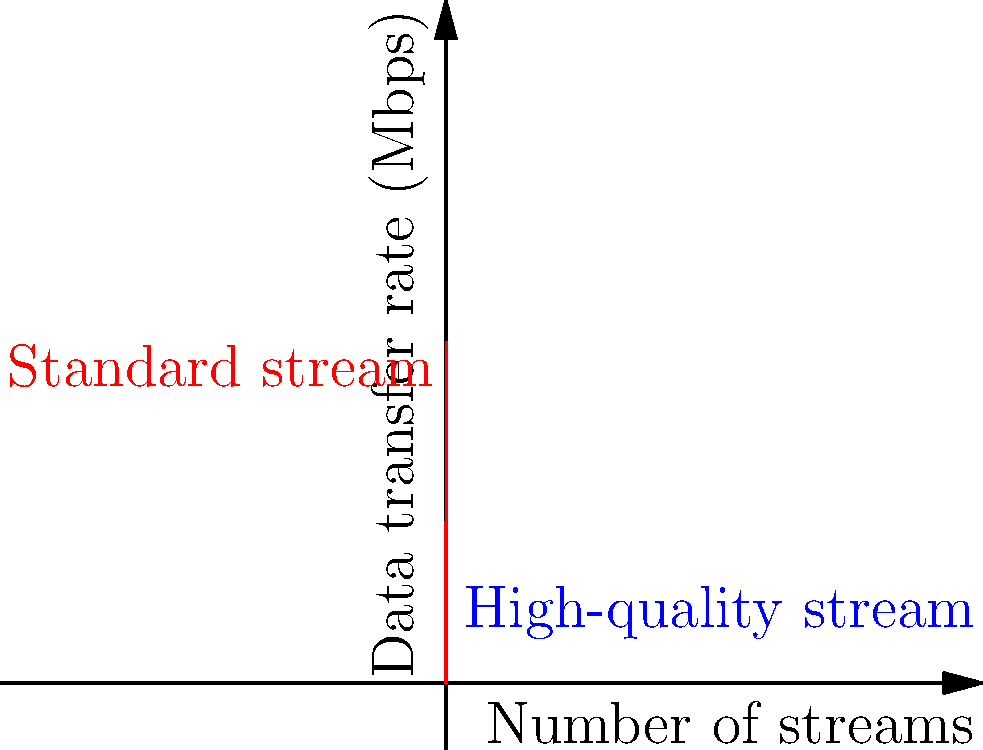A live event producer is setting up a video streaming system for a multi-camera production. The data transfer rate (in Mbps) for high-quality streams is modeled by the function $f(x) = 50x^2$, where $x$ is the number of simultaneous streams. For standard quality streams, the rate is modeled by $g(x) = 500x$. At what number of streams does the data transfer rate for high-quality streams surpass that of standard streams? What is the rate at this crossover point? To solve this problem, we need to find the point where the two functions intersect:

1) Set the functions equal to each other:
   $50x^2 = 500x$

2) Rearrange the equation:
   $50x^2 - 500x = 0$

3) Factor out the common term:
   $50x(x - 10) = 0$

4) Solve for x:
   $x = 0$ or $x = 10$
   Since we're dealing with a positive number of streams, $x = 10$ is our solution.

5) To find the rate at this crossover point, we can substitute $x = 10$ into either function:
   $f(10) = 50(10)^2 = 5000$ Mbps
   $g(10) = 500(10) = 5000$ Mbps

Therefore, the high-quality stream surpasses the standard stream at 10 simultaneous streams, with a data transfer rate of 5000 Mbps.
Answer: 10 streams; 5000 Mbps 